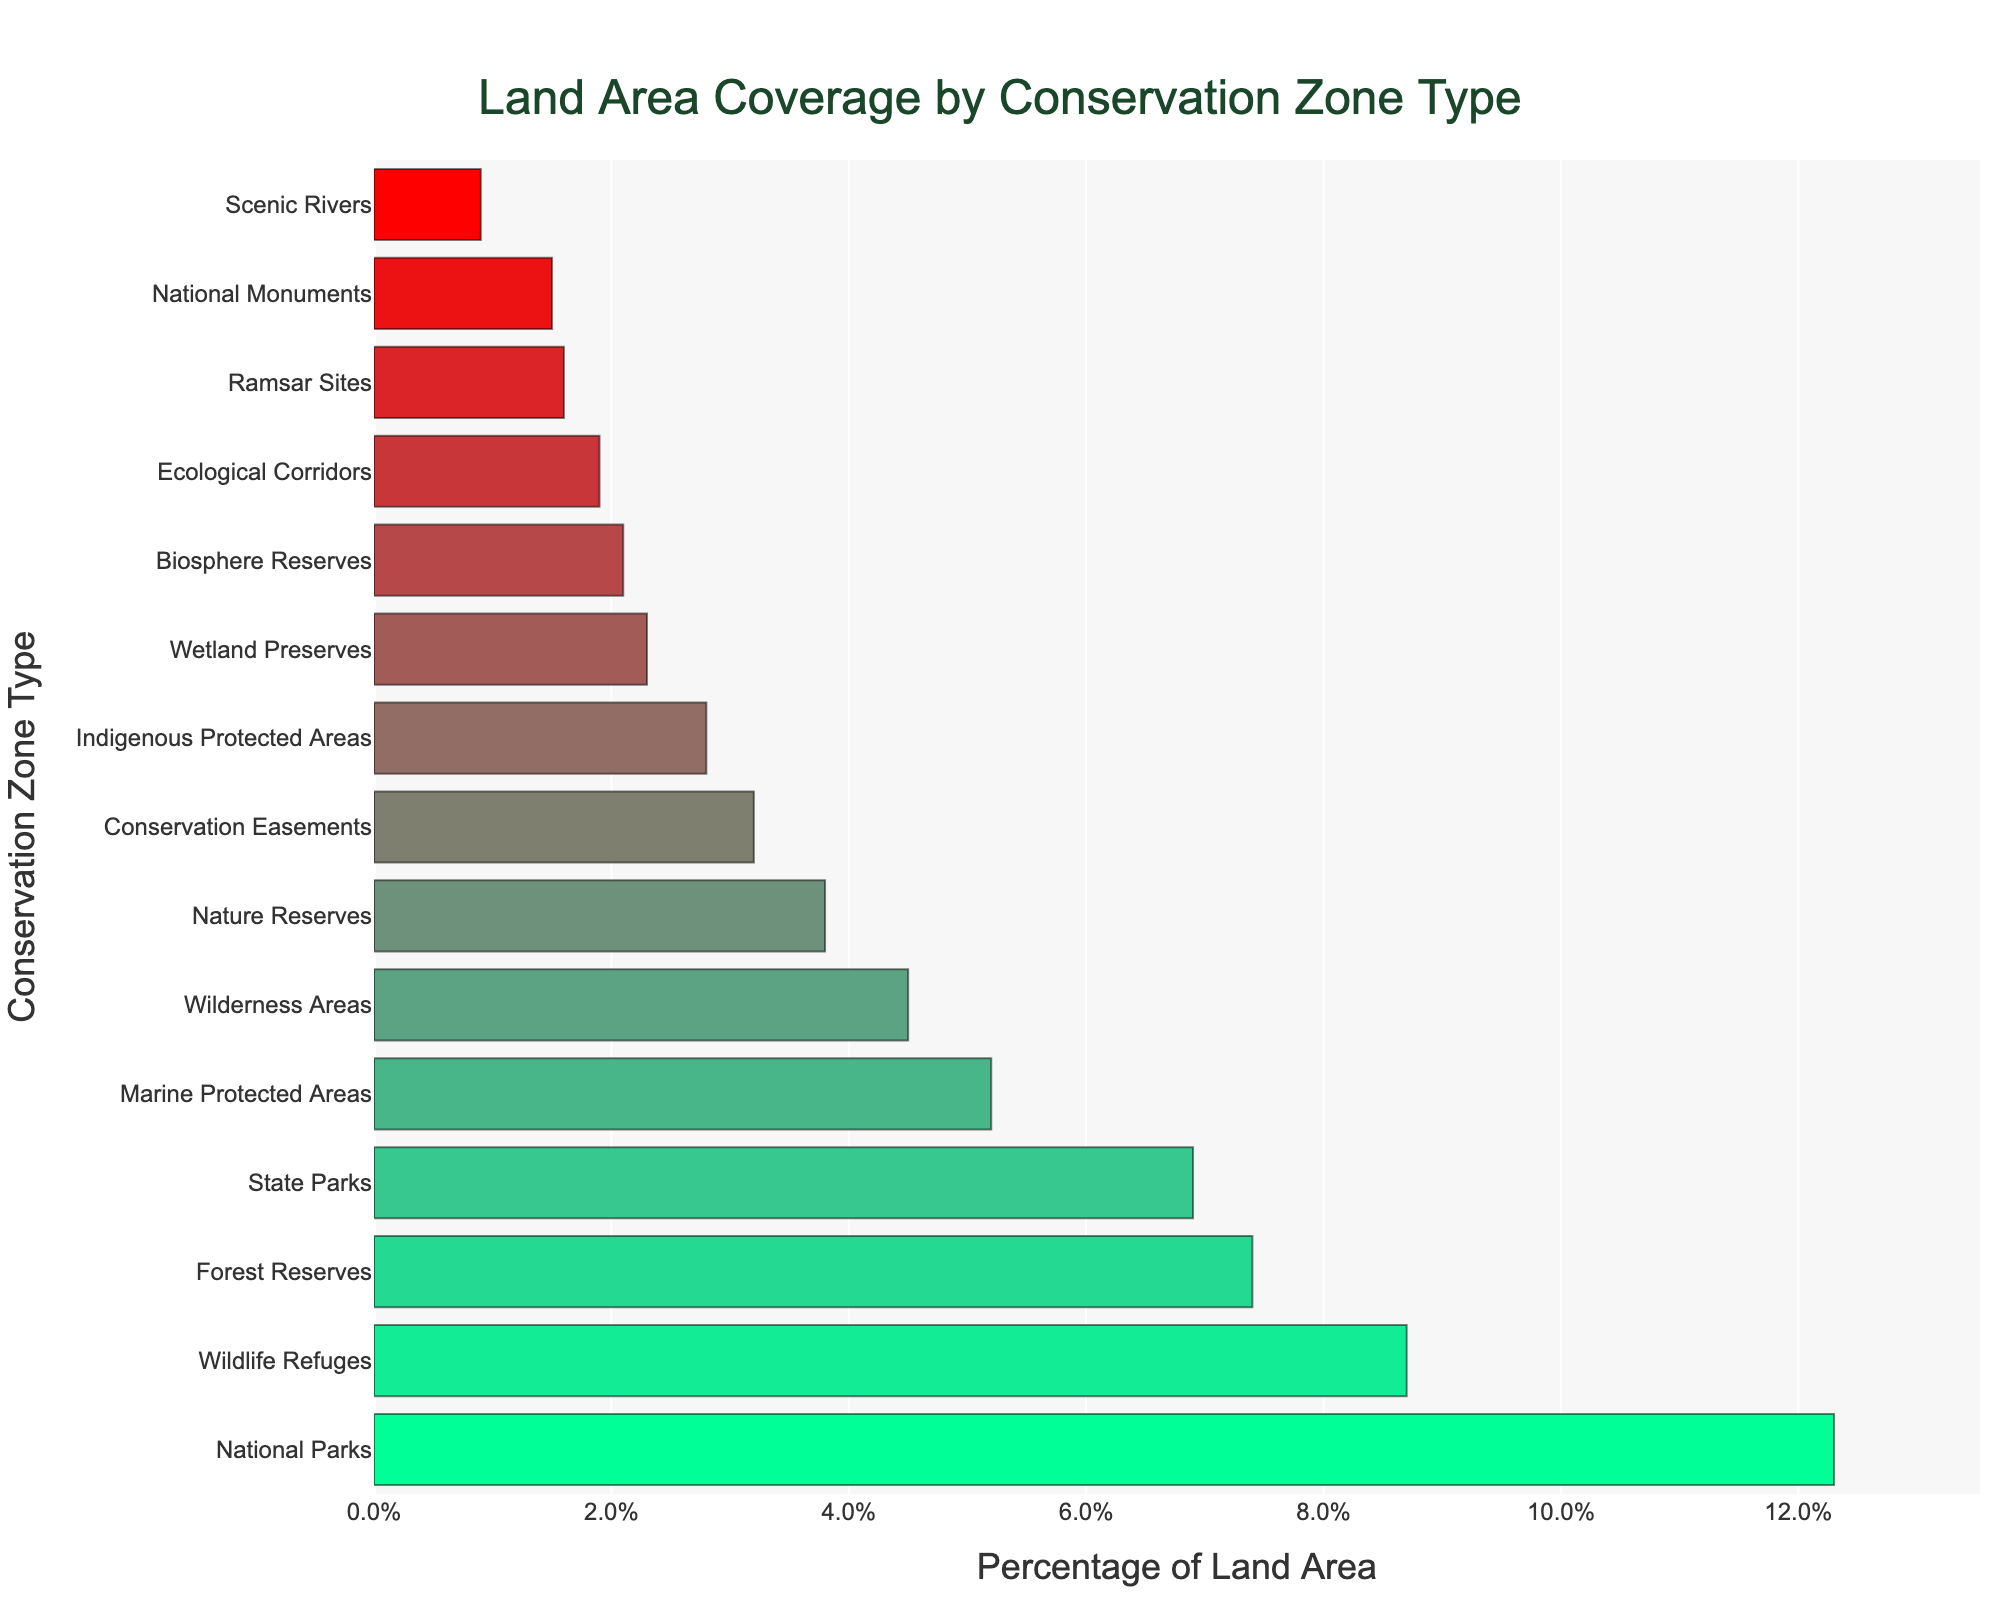Which conservation zone type has the highest percentage of land area coverage? Refer to the length of the bars to identify the longest one, which represents the conservation zone type with the highest percentage coverage. The National Parks bar is the longest.
Answer: National Parks What is the combined percentage of land area covered by Marine Protected Areas and State Parks? Add the percentage of land area for Marine Protected Areas (5.2) and State Parks (6.9). The calculation is 5.2 + 6.9 = 12.1.
Answer: 12.1 How much more land area does National Parks cover compared to Forest Reserves? Subtract the percentage of land area covered by Forest Reserves (7.4) from that of National Parks (12.3). The calculation is 12.3 - 7.4 = 4.9.
Answer: 4.9 Which conservation zone types have between 2% and 4% land area coverage? Identify the bars with lengths representing percentages between 2% and 4%. These are Nature Reserves (3.8), Conservation Easements (3.2), Wetland Preserves (2.3), and Biosphere Reserves (2.1).
Answer: Nature Reserves, Conservation Easements, Wetland Preserves, Biosphere Reserves Are there more conservation zone types with land area coverage above 5% or below 5%? Count the number of bars with lengths representing percentages above 5% and those below 5%. There are 5 types above 5% (National Parks, Wildlife Refuges, Forest Reserves, State Parks, Marine Protected Areas) and 10 types below 5%.
Answer: Below 5% What is the average percentage of land area covered by National Monuments, Ramsar Sites, and Indigenous Protected Areas? Add the percentages for National Monuments (1.5), Ramsar Sites (1.6), and Indigenous Protected Areas (2.8), and then divide by 3. The calculation is (1.5 + 1.6 + 2.8)/3 ≈ 1.97.
Answer: 1.97 Identify the conservation zone type with the lowest percentage of land area coverage and its percentage value. The shortest bar corresponds to Scenic Rivers.
Answer: Scenic Rivers, 0.9 How does the percentage of land area covered by Wilderness Areas compare to Nature Reserves? Compare the lengths of the bars. The bar for Wilderness Areas represents 4.5%, and the bar for Nature Reserves represents 3.8%. 4.5 is greater than 3.8.
Answer: Wilderness Areas cover more What is the total percentage of land area covered by the top three conservation zone types? Add the percentages for the three longest bars: National Parks (12.3), Wildlife Refuges (8.7), and Forest Reserves (7.4). The calculation is 12.3 + 8.7 + 7.4 = 28.4.
Answer: 28.4 